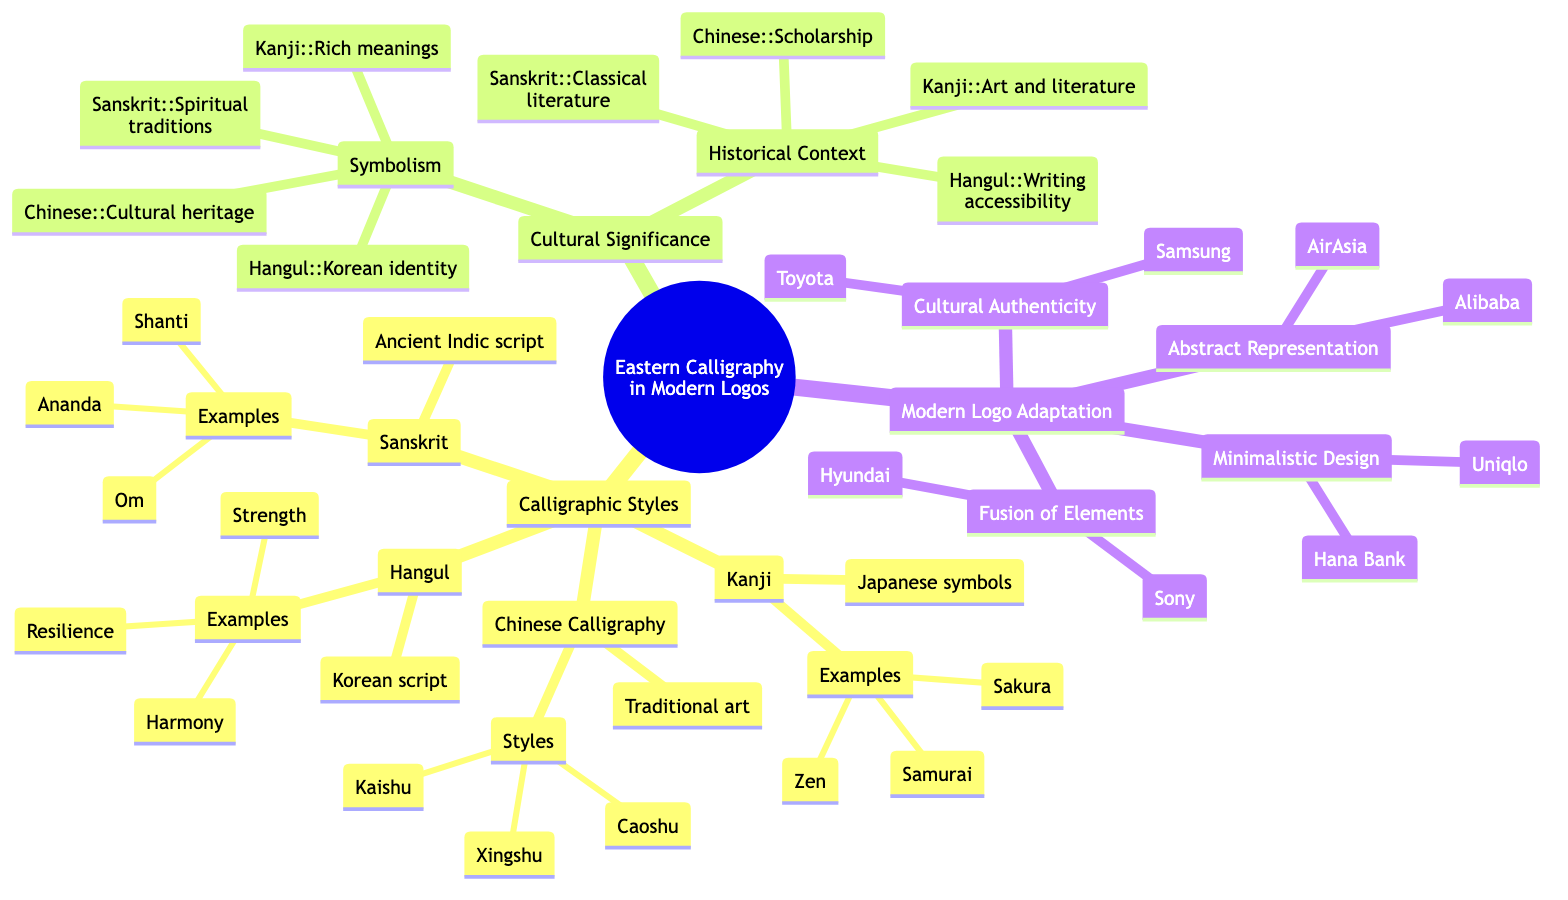What is the main focus of the diagram? The main focus of the diagram is the integration of Eastern calligraphy in modern logo design, as indicated in the root node.
Answer: Integration of Eastern Calligraphy in Modern Logo Design How many calligraphic styles are listed? The diagram lists four calligraphic styles: Kanji, Chinese Calligraphy, Hangul, and Sanskrit. By counting these specific nodes under the "Calligraphic Styles" branch, we reach the total.
Answer: 4 What is an example of Kanji? The examples listed under Kanji include Zen, Samurai, and Sakura. Zen is one of the examples mentioned directly in the diagram.
Answer: Zen Which calligraphic style includes "Caoshu"? "Caoshu" is listed under the "Chinese Calligraphy" node, indicating that it is one of the specific styles mentioned for that category in the diagram.
Answer: Chinese Calligraphy What cultural significance is linked with Hangul? The diagram specifies that Hangul reflects Korean identity and historical resilience, linking this cultural significance directly with the Hangul style.
Answer: Korean identity and historical resilience Which logo design technique is used by "Alibaba"? "Abstract Representation" is the technique associated with the logo design of Alibaba, as pointed out in the "Adaptation into Modern Logos" section under its corresponding branch.
Answer: Abstract Representation What is the technique used for minimizing complexity in logo design? The technique associated with minimizing complexity in logo design is "Minimalistic Design," which simplifies complex symbols into minimal forms, as detailed in the respective section.
Answer: Minimalistic Design How many logos are mentioned under Cultural Authenticity? The section on Cultural Authenticity lists two logos, Toyota and Samsung, indicating that there are two specific examples given for this technique.
Answer: 2 Which calligraphic script connects with spiritual traditions? The Sanskrit calligraphic style is explicitly mentioned as connecting with spiritual and philosophical traditions within the Cultural Significance section of the diagram.
Answer: Sanskrit 